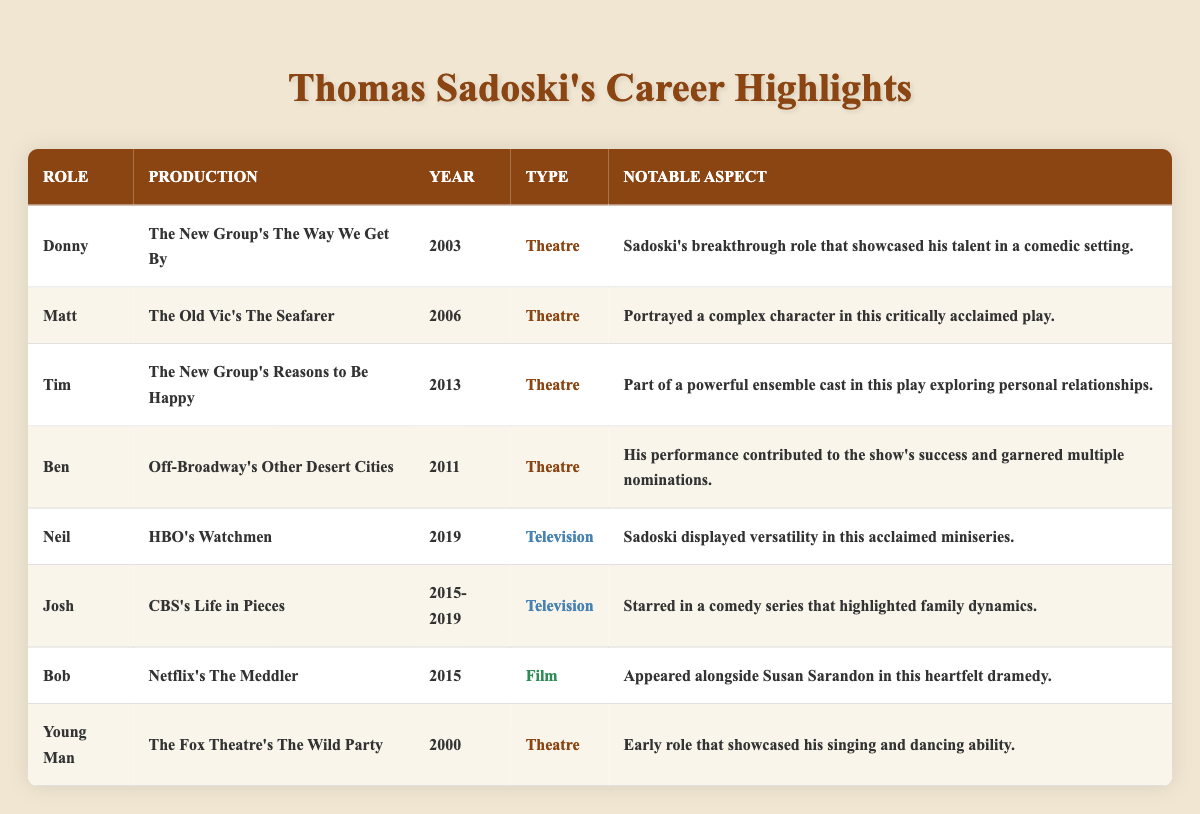What role did Thomas Sadoski play in 2003? According to the table, the role he played in 2003 is Donny in "The New Group's The Way We Get By."
Answer: Donny How many years did Thomas Sadoski appear in "CBS's Life in Pieces"? The show ran from 2015 to 2019, which is a span of 5 years including both start and end dates.
Answer: 5 years Which production features a character named Tim? The table indicates that Tim is a character in "The New Group's Reasons to Be Happy."
Answer: The New Group's Reasons to Be Happy True or false: Thomas Sadoski starred in more theatre roles than television roles. There are 5 theatre roles and 3 television roles listed in the table, making the statement true.
Answer: True What is the notable aspect of Thomas Sadoski's role as Neil? The notable aspect mentioned for Neil in "HBO's Watchmen" is that Sadoski displayed versatility in this acclaimed miniseries.
Answer: Displayed versatility What role from Thomas Sadoski's career was performed in Off-Broadway? The table shows that the role of Ben in "Off-Broadway's Other Desert Cities" is his Off-Broadway role.
Answer: Ben In which year did Thomas Sadoski perform in "The Wild Party"? According to the table, he performed in "The Wild Party" in the year 2000.
Answer: 2000 Which character appeared alongside Susan Sarandon? The character Bob from "Netflix's The Meddler" is listed as appearing alongside Susan Sarandon.
Answer: Bob What is the total number of theatre roles listed for Thomas Sadoski? There are 5 theatre roles listed in the table: Donny, Matt, Tim, Ben, and Young Man. Therefore, the total is 5.
Answer: 5 Name the production where Thomas Sadoski played a complex character. The production where he played a complex character is "The Old Vic's The Seafarer," where he portrayed Matt.
Answer: The Old Vic's The Seafarer List all productions Thomas Sadoski was part of in 2015. The table shows he participated in "CBS's Life in Pieces" and "Netflix's The Meddler" in 2015.
Answer: CBS's Life in Pieces, Netflix's The Meddler 